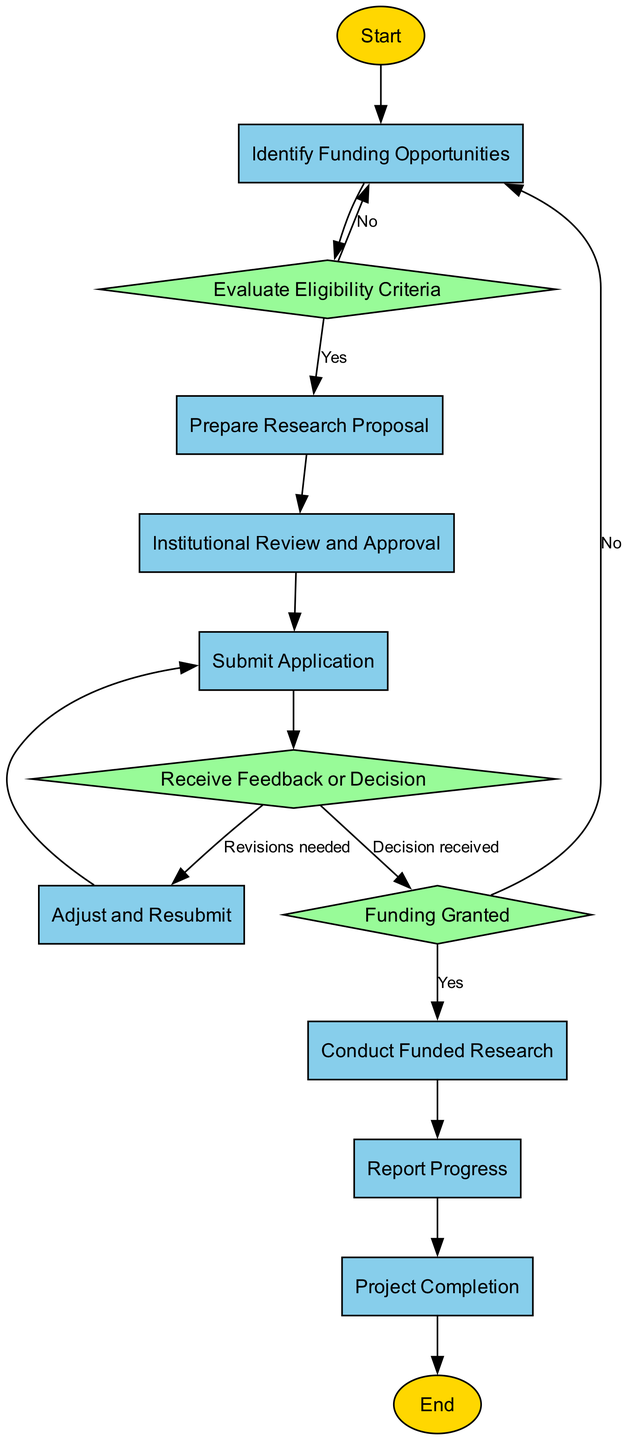What is the starting point of the workflow? The diagram begins with the "Start" node, which indicates the very first step in the grant application process. This is where the entire workflow initiates.
Answer: Start How many decision nodes are present in the workflow? The workflow includes three decision nodes: "Evaluate Eligibility Criteria," "Receive Feedback or Decision," and "Funding Granted." These nodes determine the flow based on certain criteria being met.
Answer: 3 What action follows after "Prepare Research Proposal"? After preparing the research proposal, the next step in the workflow is "Institutional Review and Approval," which requires internal review and approval by the university.
Answer: Institutional Review and Approval What happens if the eligibility criteria are not met? If the eligibility criteria are not met, the workflow loops back to the "Identify Funding Opportunities" node, suggesting that the researcher should search for different grants.
Answer: Identify Funding Opportunities What is the final step of the application process? The last step in the workflow is "End," which signifies the conclusion of the entire grant application process after the project has been completed and all required reports submitted.
Answer: End If feedback suggests changes, which process is undertaken next? If feedback indicates revisions are needed, the next process is "Adjust and Resubmit," during which the research proposal is updated as needed before resubmission.
Answer: Adjust and Resubmit Which node does "Conduct Funded Research" lead to? The "Conduct Funded Research" step leads to the "Report Progress" node, indicating the need for ongoing reporting during the research project.
Answer: Report Progress What is checked after receiving feedback from the funding agency? After receiving feedback, the next step is to check if adjustments are required based on the feedback categorized under the "Receive Feedback or Decision" node.
Answer: Adjustments required What type of node is "Funding Granted"? The "Funding Granted" node is a decision node, which assesses whether the research project has been funded or if alternative funding options should be sought.
Answer: Decision Node 